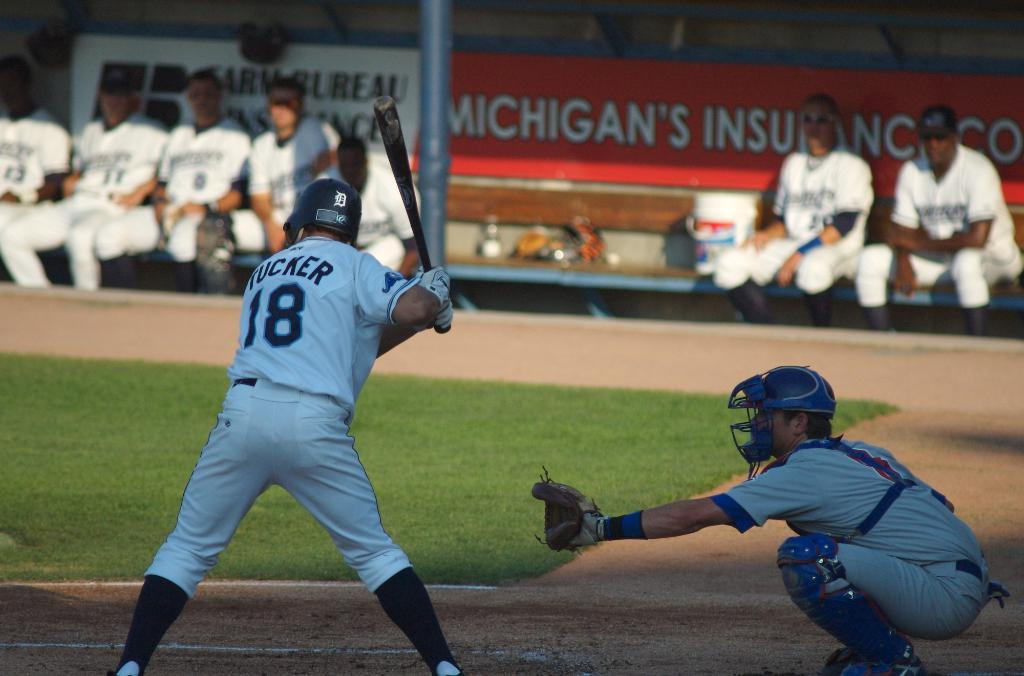<image>
Share a concise interpretation of the image provided. The baseball game is sponsored by Michigan's Insurance Co. 